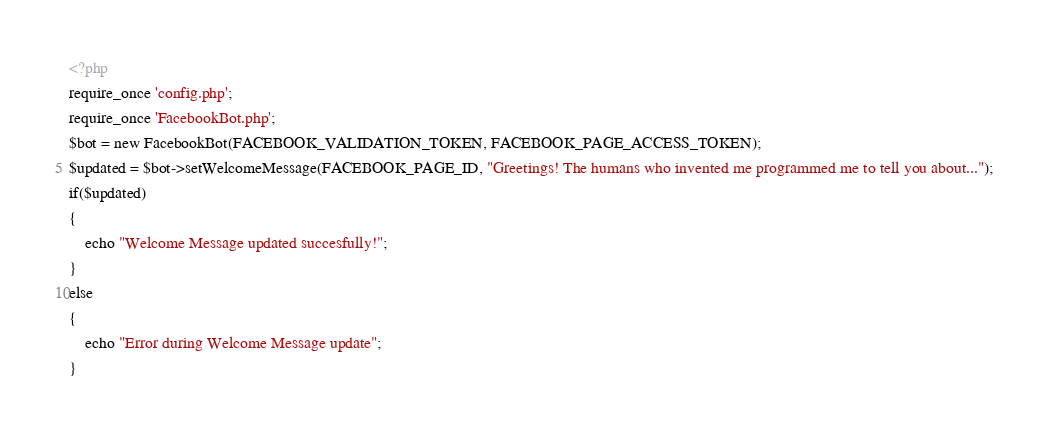Convert code to text. <code><loc_0><loc_0><loc_500><loc_500><_PHP_><?php
require_once 'config.php';
require_once 'FacebookBot.php';
$bot = new FacebookBot(FACEBOOK_VALIDATION_TOKEN, FACEBOOK_PAGE_ACCESS_TOKEN);
$updated = $bot->setWelcomeMessage(FACEBOOK_PAGE_ID, "Greetings! The humans who invented me programmed me to tell you about...");
if($updated)
{
	echo "Welcome Message updated succesfully!";
}
else 
{
	echo "Error during Welcome Message update";
}</code> 